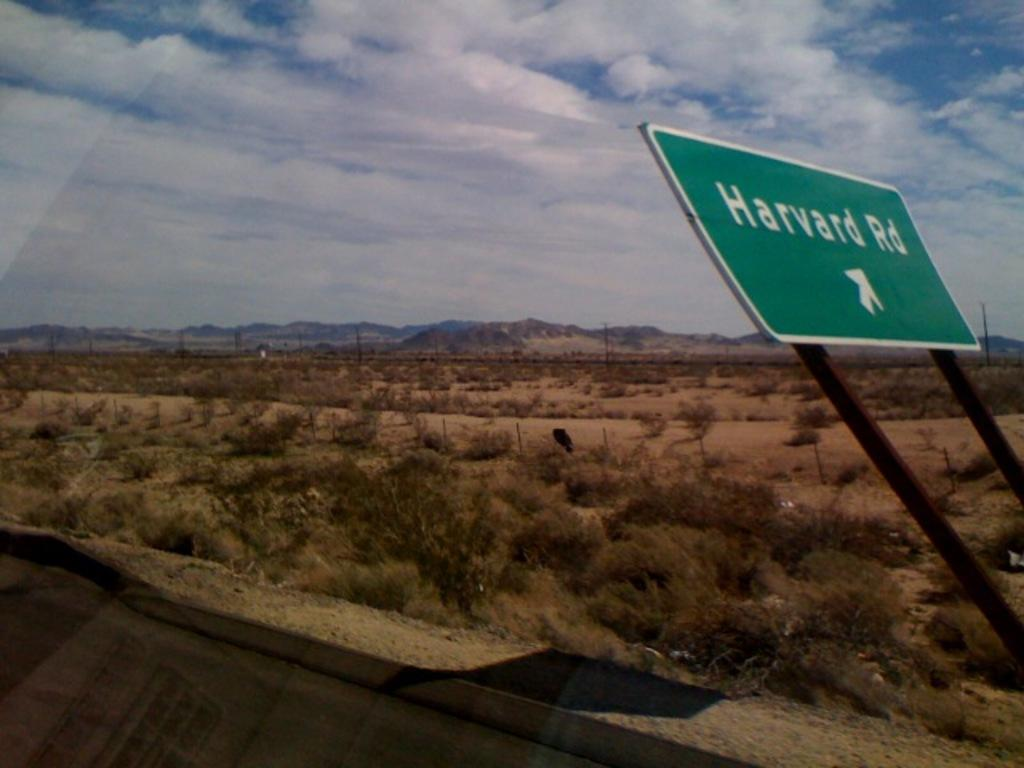<image>
Summarize the visual content of the image. Harvard Road is off to the right through the desert. 